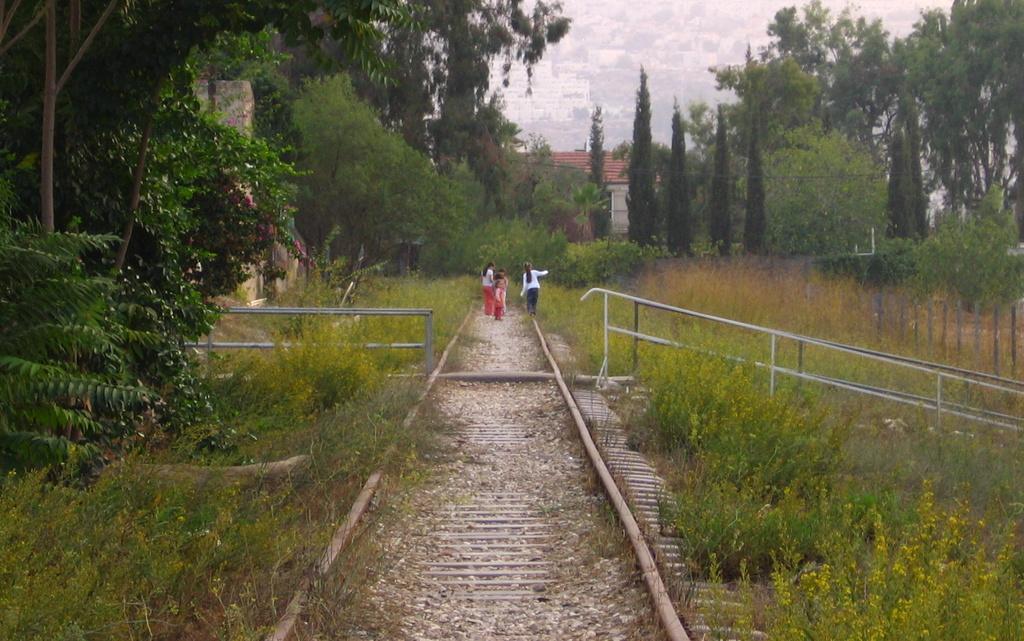Please provide a concise description of this image. In this image we can see some people standing on the ground, there are trees grass and wall on the left side of the image and on the left side of the image there are trees and poles and in the background there is a building and sky. 